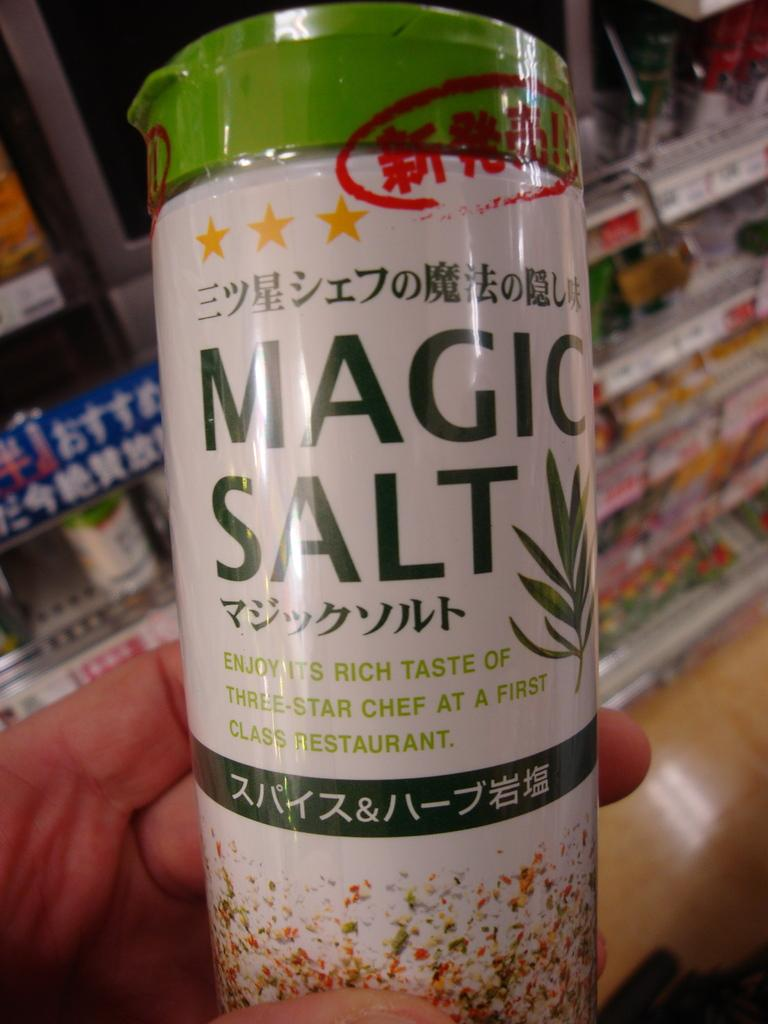<image>
Describe the image concisely. A person hold a bottle of "Magic Salt" that has writing in an Asian language on it. 